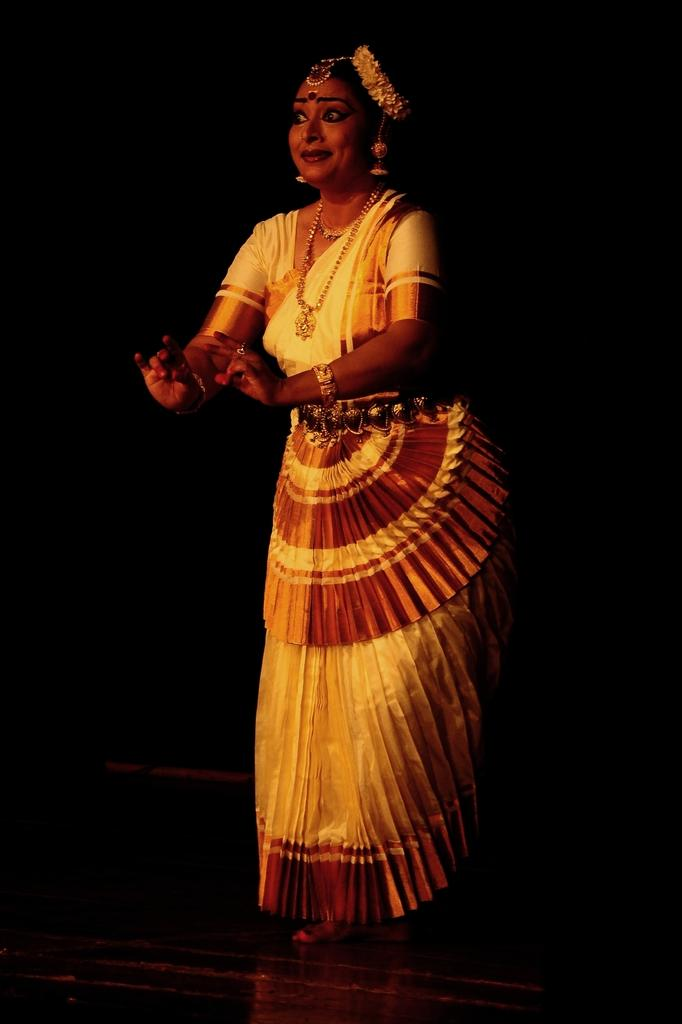Who is the main subject in the image? There is a woman in the image. What is the woman wearing? The woman is wearing clothes, a neck chain, a finger ring, a bracelet, and earrings. What might the woman be doing in the image? It appears that the woman is dancing. What is the color of the background in the image? The background of the image is dark. How many numbers can be seen on the ground in the image? There are no numbers visible on the ground in the image. What type of support is the woman using to dance in the image? The image does not show any specific support being used for dancing; it only shows the woman dancing. 